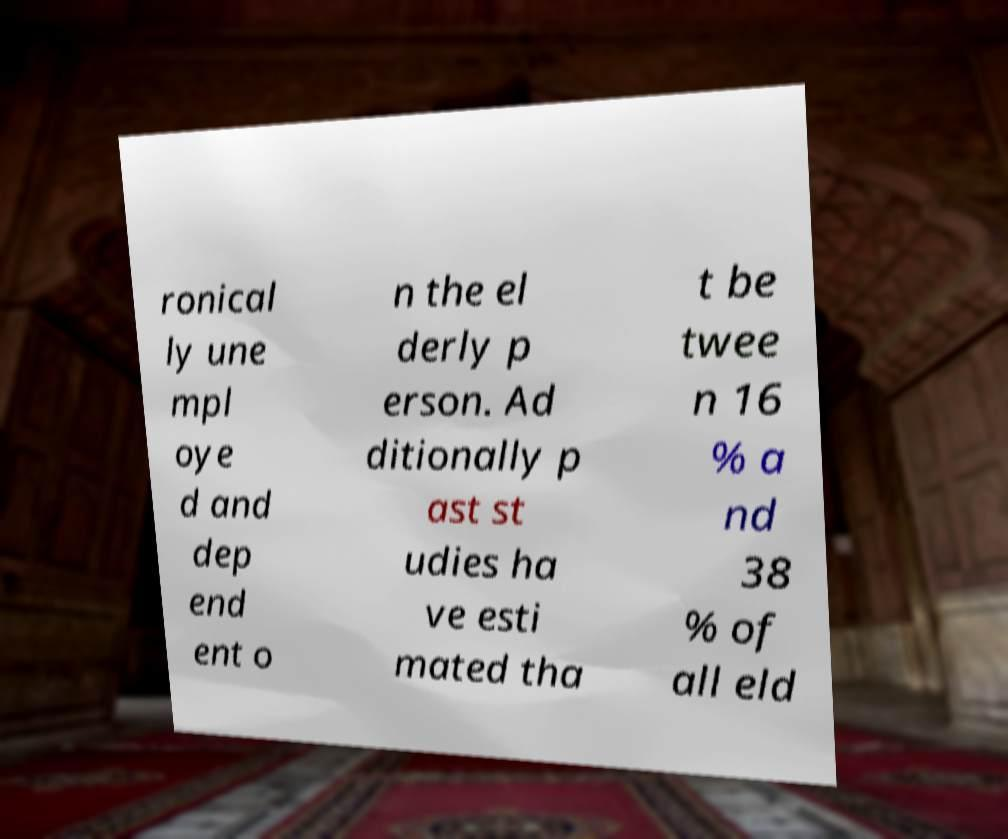Could you assist in decoding the text presented in this image and type it out clearly? ronical ly une mpl oye d and dep end ent o n the el derly p erson. Ad ditionally p ast st udies ha ve esti mated tha t be twee n 16 % a nd 38 % of all eld 